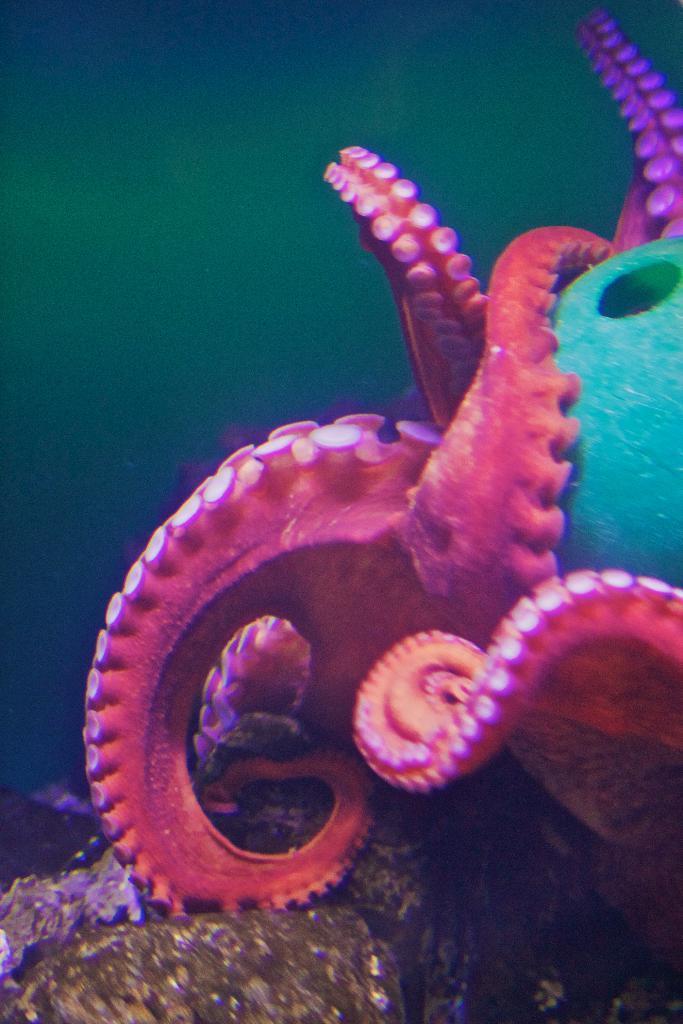Describe this image in one or two sentences. The picture is clicked inside the water. In the center of the picture there is an octopus. At the bottom it is rock. 